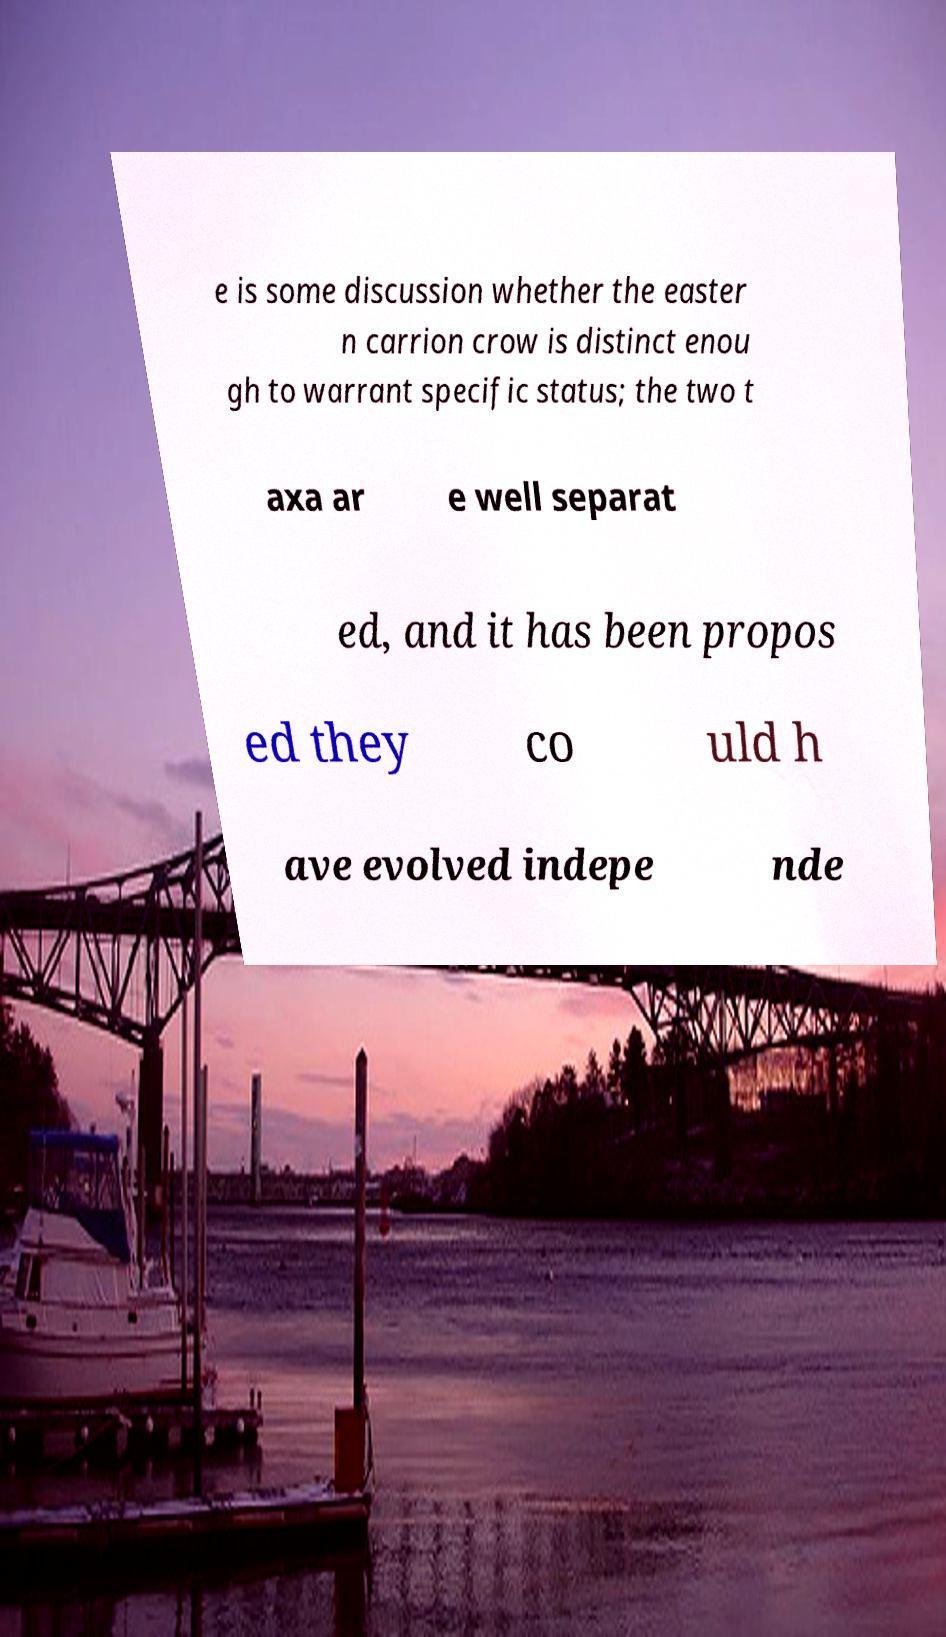Please identify and transcribe the text found in this image. e is some discussion whether the easter n carrion crow is distinct enou gh to warrant specific status; the two t axa ar e well separat ed, and it has been propos ed they co uld h ave evolved indepe nde 